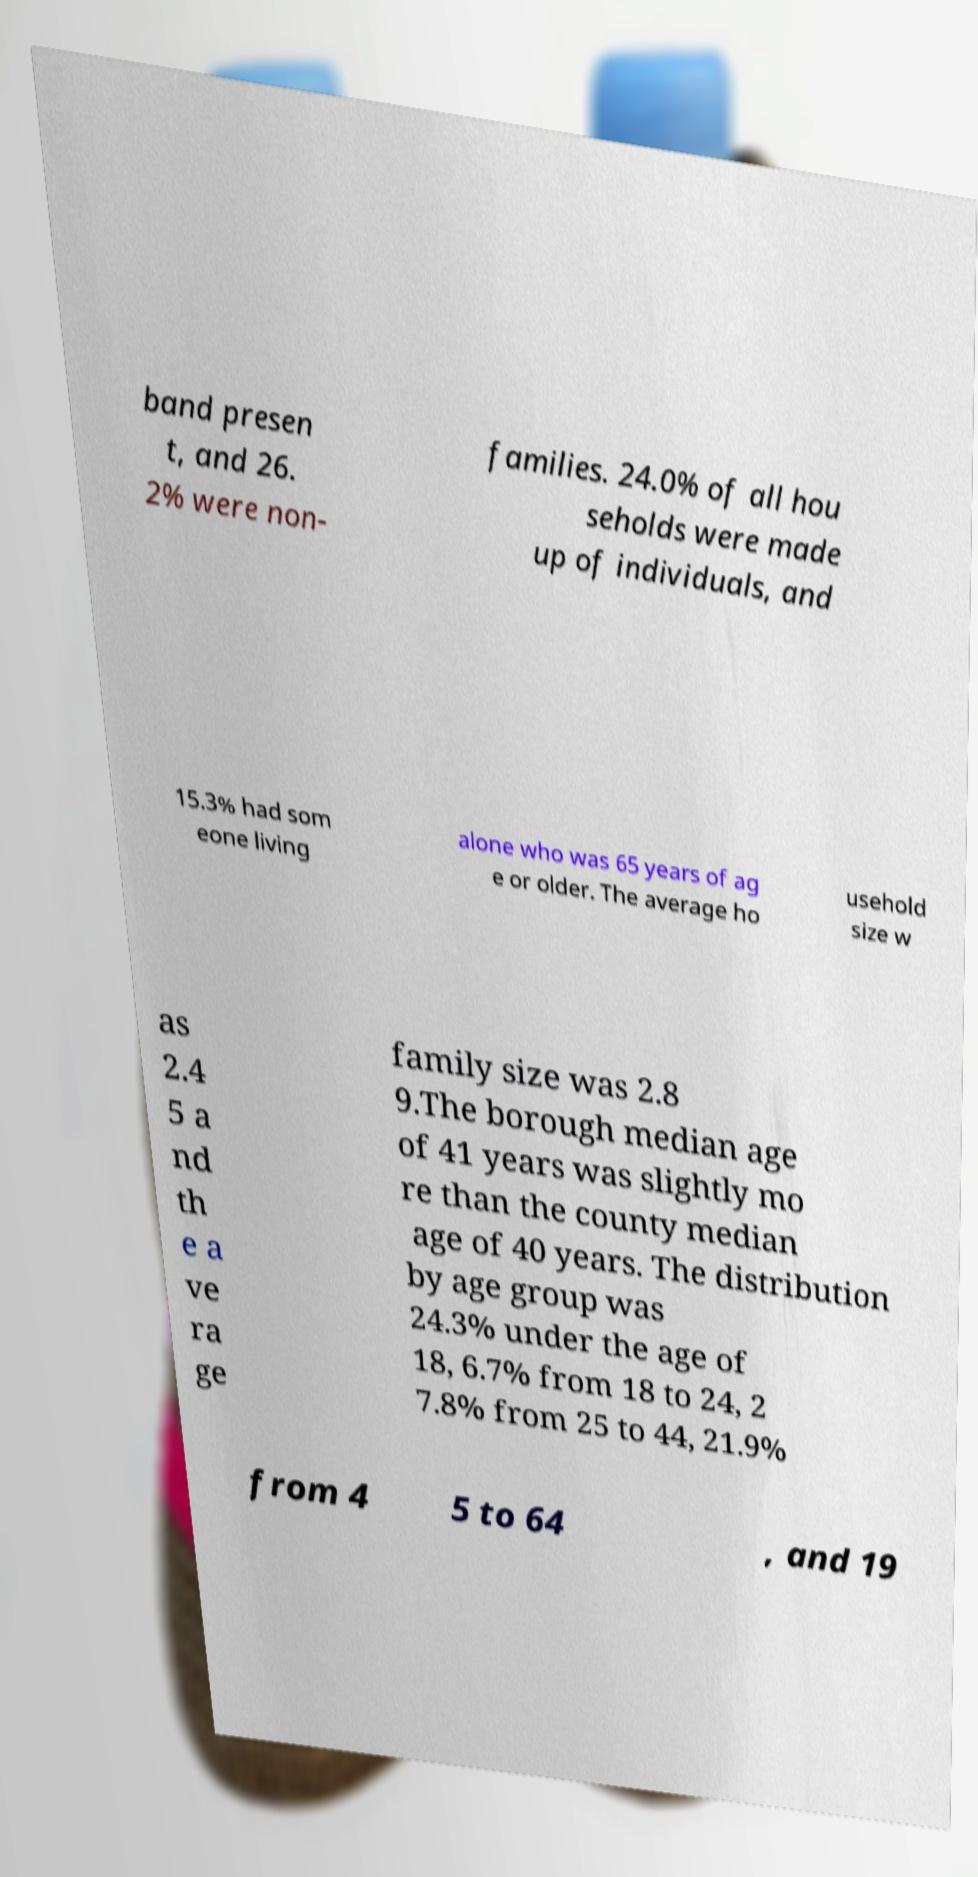For documentation purposes, I need the text within this image transcribed. Could you provide that? band presen t, and 26. 2% were non- families. 24.0% of all hou seholds were made up of individuals, and 15.3% had som eone living alone who was 65 years of ag e or older. The average ho usehold size w as 2.4 5 a nd th e a ve ra ge family size was 2.8 9.The borough median age of 41 years was slightly mo re than the county median age of 40 years. The distribution by age group was 24.3% under the age of 18, 6.7% from 18 to 24, 2 7.8% from 25 to 44, 21.9% from 4 5 to 64 , and 19 